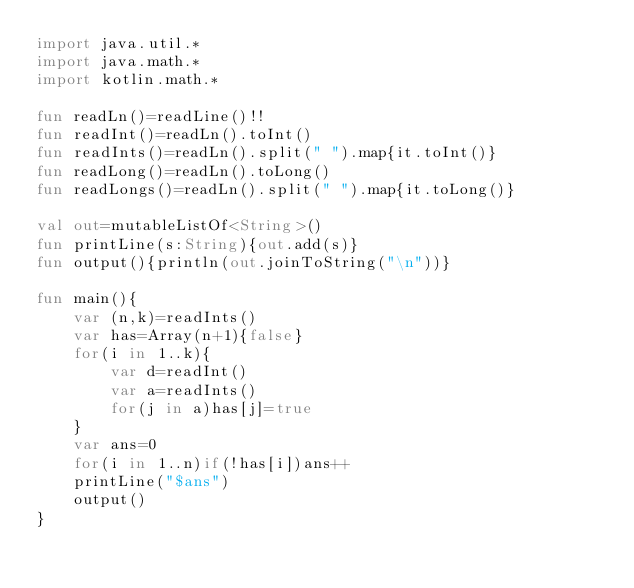Convert code to text. <code><loc_0><loc_0><loc_500><loc_500><_Kotlin_>import java.util.*
import java.math.*
import kotlin.math.*

fun readLn()=readLine()!!
fun readInt()=readLn().toInt()
fun readInts()=readLn().split(" ").map{it.toInt()}
fun readLong()=readLn().toLong()
fun readLongs()=readLn().split(" ").map{it.toLong()}

val out=mutableListOf<String>()
fun printLine(s:String){out.add(s)}
fun output(){println(out.joinToString("\n"))}

fun main(){
    var (n,k)=readInts()
    var has=Array(n+1){false}
    for(i in 1..k){
        var d=readInt()
        var a=readInts()
        for(j in a)has[j]=true
    }
    var ans=0
    for(i in 1..n)if(!has[i])ans++
    printLine("$ans")
    output()
}</code> 